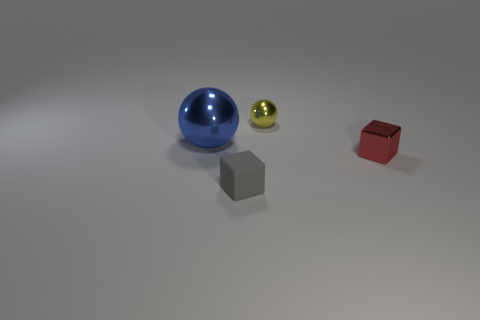What is the color of the large ball?
Offer a terse response. Blue. What size is the red thing that is made of the same material as the blue thing?
Offer a terse response. Small. There is a cube to the right of the cube to the left of the tiny red metallic thing; what number of red objects are in front of it?
Provide a succinct answer. 0. There is a matte cube; is its color the same as the cube that is to the right of the yellow metal thing?
Offer a terse response. No. What material is the cube that is in front of the tiny shiny thing that is to the right of the shiny object that is behind the big metal sphere?
Provide a short and direct response. Rubber. There is a shiny thing that is left of the rubber cube; does it have the same shape as the gray rubber thing?
Your answer should be compact. No. There is a block right of the tiny sphere; what is its material?
Provide a succinct answer. Metal. How many rubber things are small yellow balls or tiny purple things?
Keep it short and to the point. 0. Is there a brown matte sphere of the same size as the gray thing?
Keep it short and to the point. No. Is the number of blocks on the right side of the red shiny block greater than the number of blue spheres?
Offer a terse response. No. 